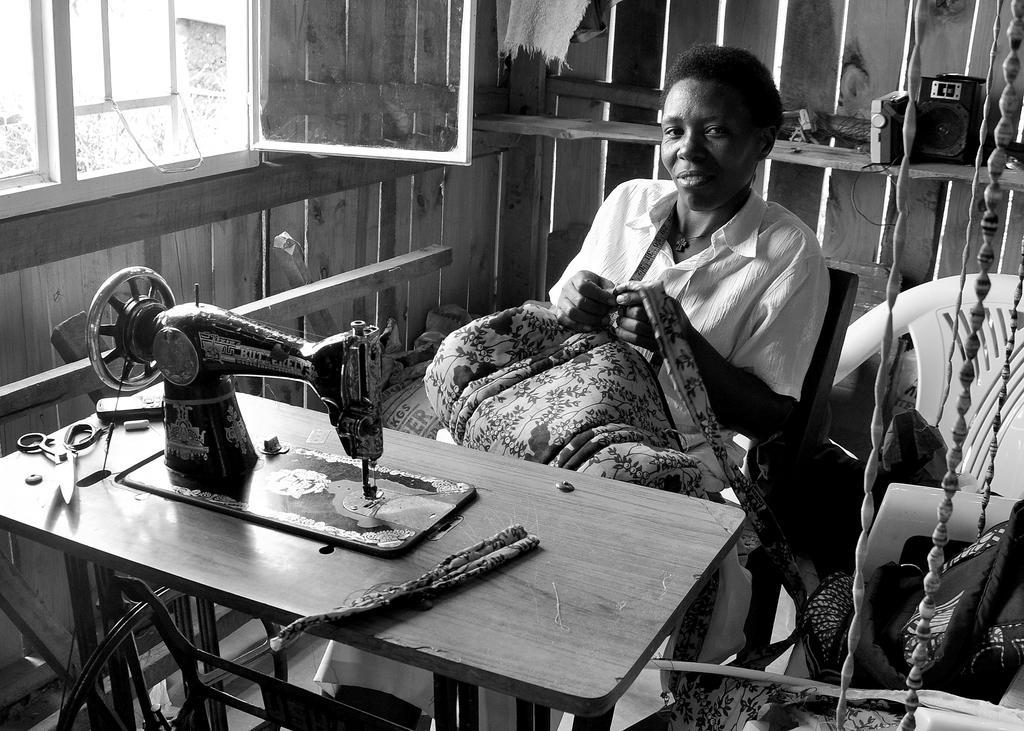Please provide a concise description of this image. In this image there is one person who is sitting on chair, and he is holding some cloth. In front of her there is a machine, on the machine there is cloth, scissor, phone, some object. And on the right side of the image there are two chairs, and on the cars there are some clothes. And in the background there are some objects and wooden wall, on the left side of the image there is a window. 